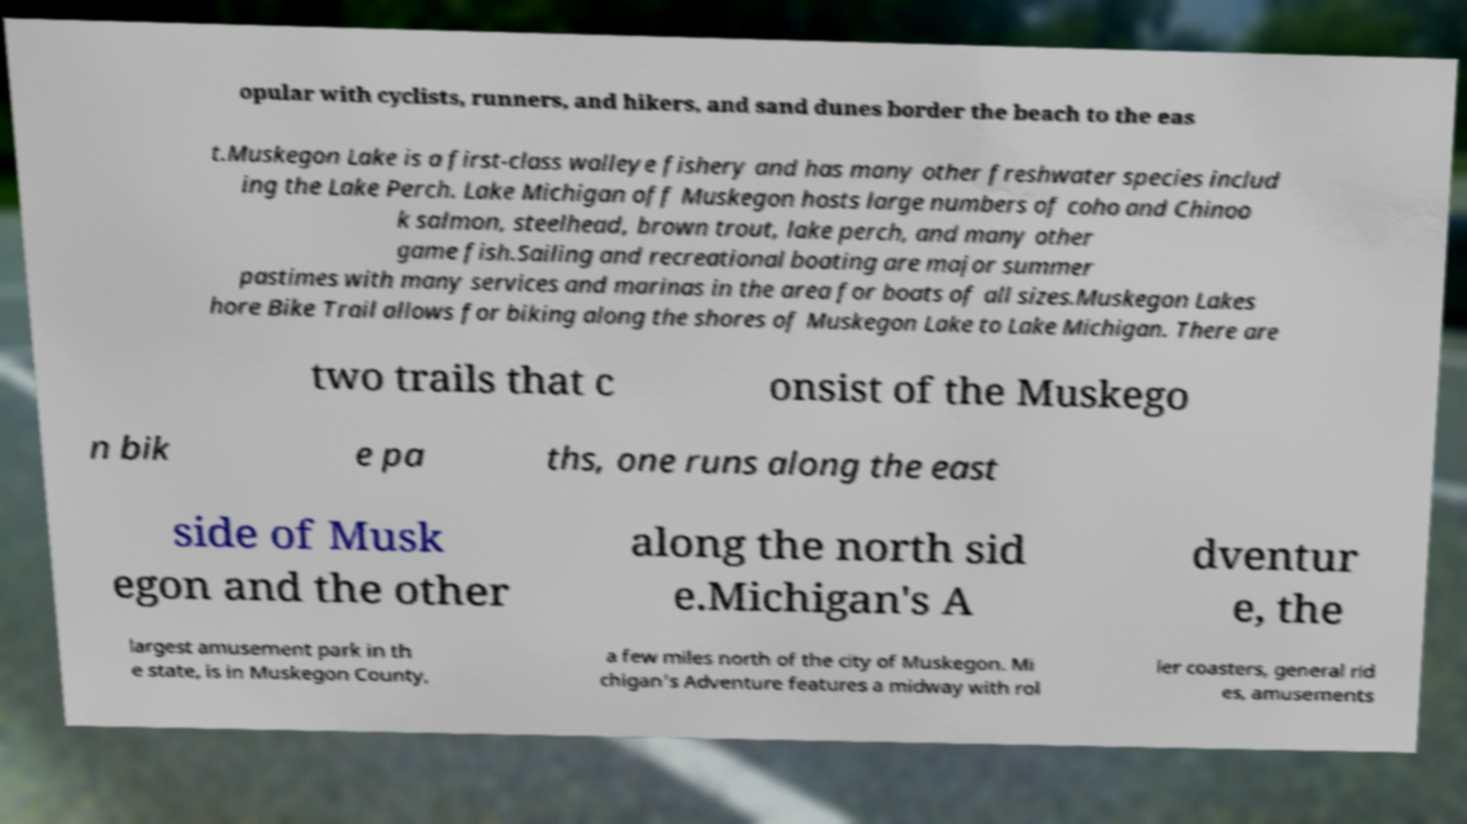Could you assist in decoding the text presented in this image and type it out clearly? opular with cyclists, runners, and hikers, and sand dunes border the beach to the eas t.Muskegon Lake is a first-class walleye fishery and has many other freshwater species includ ing the Lake Perch. Lake Michigan off Muskegon hosts large numbers of coho and Chinoo k salmon, steelhead, brown trout, lake perch, and many other game fish.Sailing and recreational boating are major summer pastimes with many services and marinas in the area for boats of all sizes.Muskegon Lakes hore Bike Trail allows for biking along the shores of Muskegon Lake to Lake Michigan. There are two trails that c onsist of the Muskego n bik e pa ths, one runs along the east side of Musk egon and the other along the north sid e.Michigan's A dventur e, the largest amusement park in th e state, is in Muskegon County, a few miles north of the city of Muskegon. Mi chigan's Adventure features a midway with rol ler coasters, general rid es, amusements 